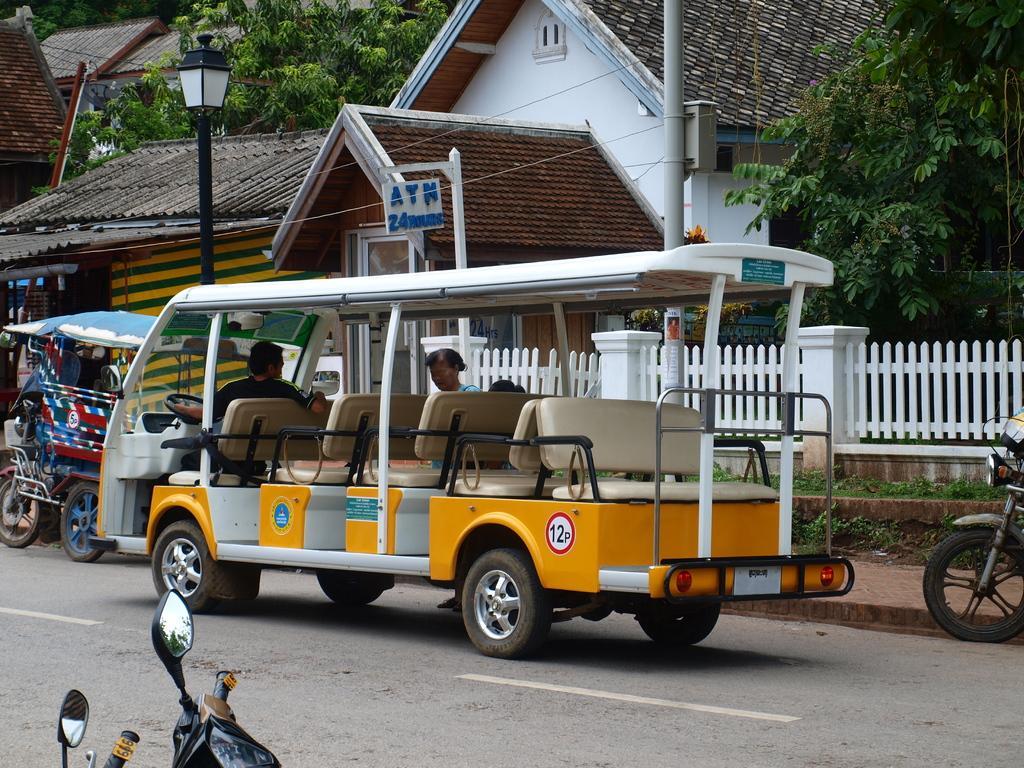How would you summarize this image in a sentence or two? In this image in the front there are bikes. In the center there are vehicles moving on the road. In the background there are houses, trees and there is a fence which is white in colour and there are poles and there is a board with some text written on it. 